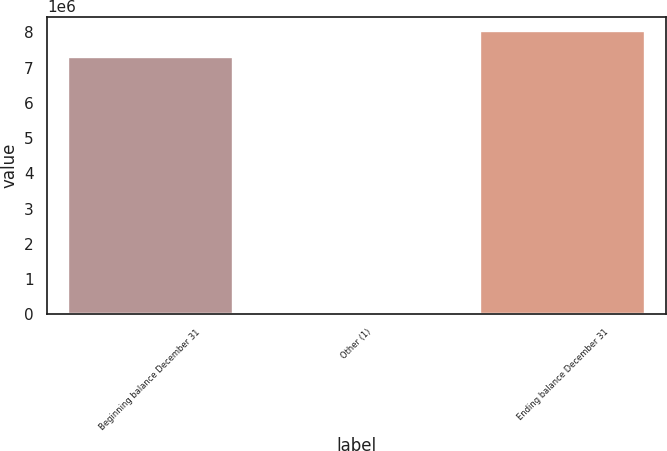Convert chart. <chart><loc_0><loc_0><loc_500><loc_500><bar_chart><fcel>Beginning balance December 31<fcel>Other (1)<fcel>Ending balance December 31<nl><fcel>7.30972e+06<fcel>12047<fcel>8.04072e+06<nl></chart> 